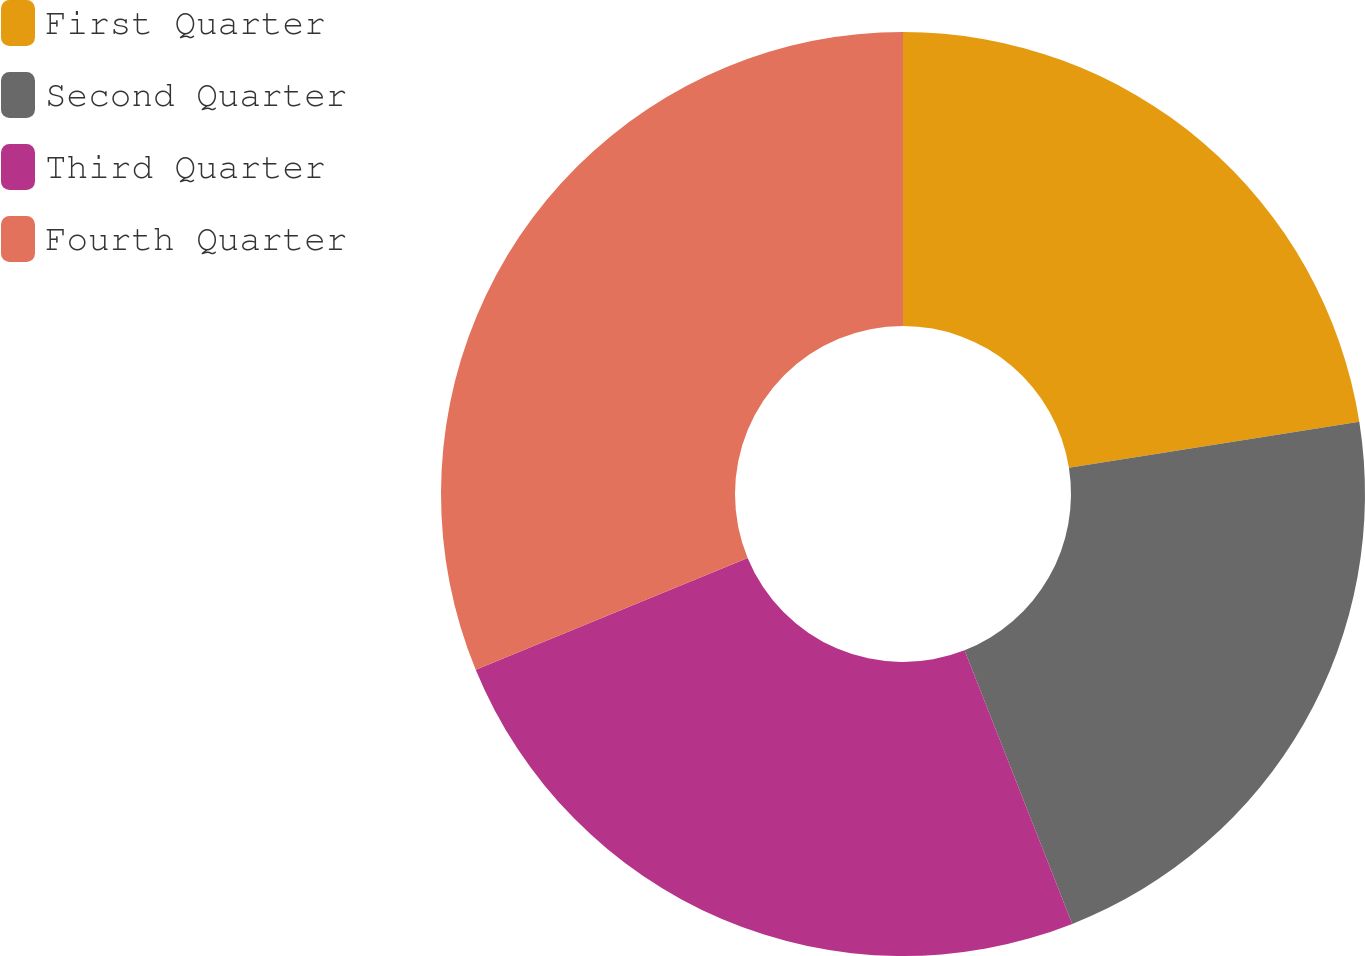Convert chart. <chart><loc_0><loc_0><loc_500><loc_500><pie_chart><fcel>First Quarter<fcel>Second Quarter<fcel>Third Quarter<fcel>Fourth Quarter<nl><fcel>22.5%<fcel>21.53%<fcel>24.76%<fcel>31.21%<nl></chart> 